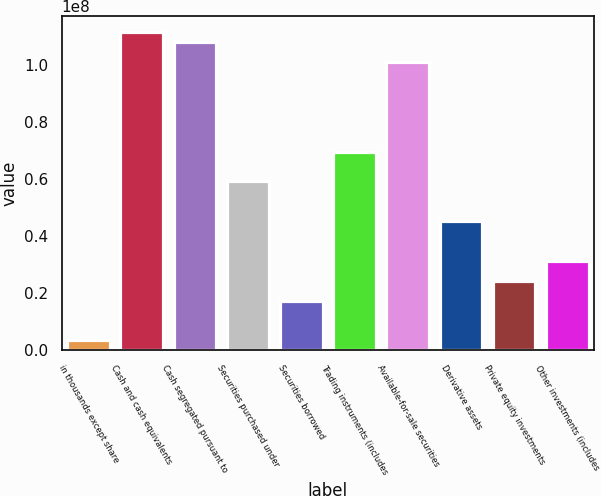Convert chart to OTSL. <chart><loc_0><loc_0><loc_500><loc_500><bar_chart><fcel>in thousands except share<fcel>Cash and cash equivalents<fcel>Cash segregated pursuant to<fcel>Securities purchased under<fcel>Securities borrowed<fcel>Trading instruments (includes<fcel>Available-for-sale securities<fcel>Derivative assets<fcel>Private equity investments<fcel>Other investments (includes<nl><fcel>3.48973e+06<fcel>1.11624e+08<fcel>1.08135e+08<fcel>5.93008e+07<fcel>1.74425e+07<fcel>6.97654e+07<fcel>1.01159e+08<fcel>4.5348e+07<fcel>2.44189e+07<fcel>3.13953e+07<nl></chart> 